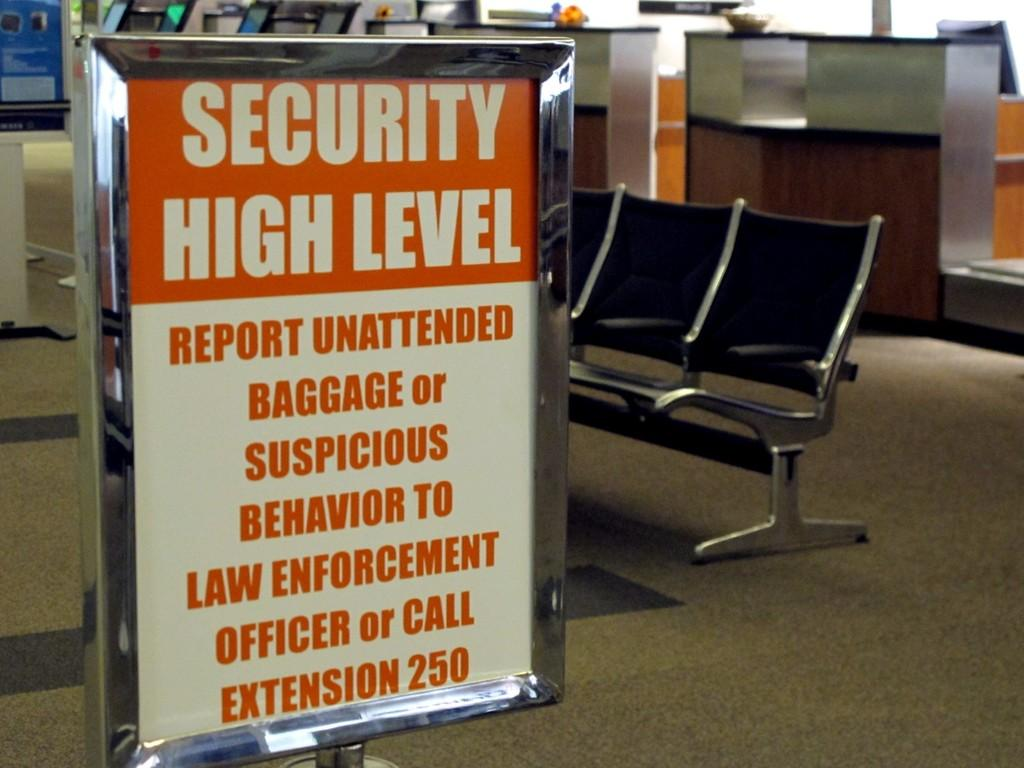<image>
Provide a brief description of the given image. A sign that says the security is high level 